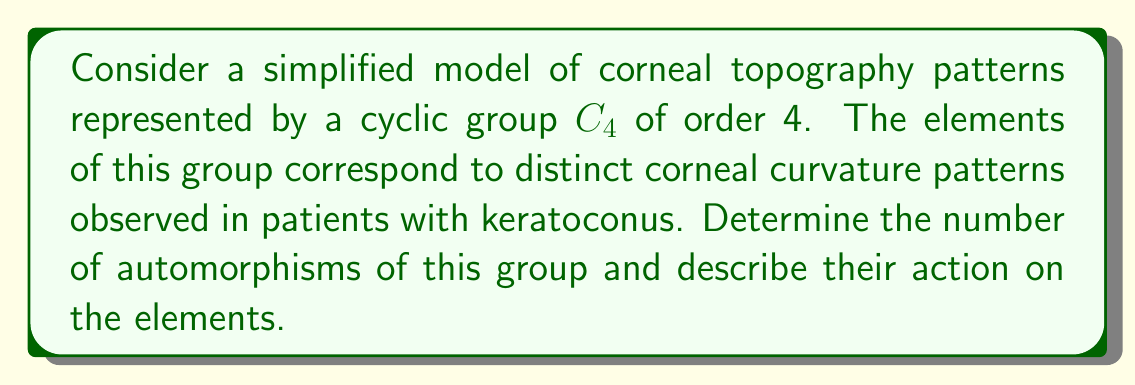Could you help me with this problem? To solve this problem, let's follow these steps:

1) First, recall that for a cyclic group $C_n$, the number of automorphisms is equal to $\phi(n)$, where $\phi$ is Euler's totient function.

2) In this case, we have $C_4$, so we need to calculate $\phi(4)$.

3) $\phi(4)$ is the number of integers less than 4 that are coprime to 4. These are 1 and 3.

4) Therefore, the number of automorphisms is 2.

5) Now, let's describe these automorphisms. Let $g$ be a generator of $C_4$. The elements of $C_4$ can be written as $\{e, g, g^2, g^3\}$, where $e$ is the identity element.

6) The two automorphisms are:
   a) The identity automorphism: $f_1(g^i) = g^i$ for all $i$.
   b) The automorphism that maps $g$ to $g^3$: $f_2(g) = g^3$, $f_2(g^2) = g^2$, $f_2(g^3) = g$.

7) In terms of corneal topography patterns, if we associate $e$ with normal curvature, $g$ with mild keratoconus, $g^2$ with moderate keratoconus, and $g^3$ with severe keratoconus, then:
   - $f_1$ represents no change in the classification of patterns.
   - $f_2$ interchanges the mild and severe cases while leaving the normal and moderate cases unchanged.
Answer: The group $C_4$ representing corneal topography patterns has 2 automorphisms. One is the identity automorphism, and the other maps the generator $g$ to $g^3$, effectively swapping the elements representing mild and severe keratoconus while leaving the elements representing normal curvature and moderate keratoconus unchanged. 